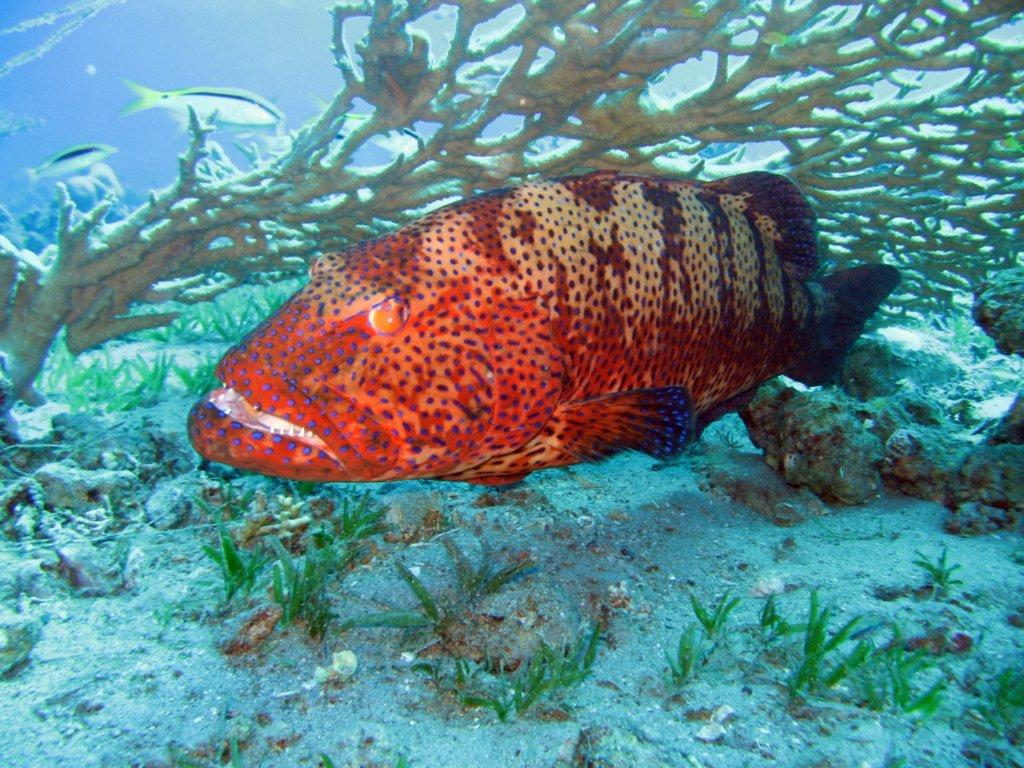What type of animal is present in the image? There is a fish in the image. What else can be seen in the image besides the fish? There are aquatic plants in the image. Can you describe the setting of the image? The image has been taken underwater. What day of the week is depicted in the image? The image does not depict a day of the week; it is a still image of a fish and aquatic plants underwater. 